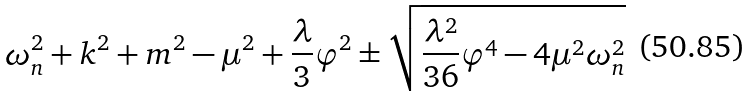Convert formula to latex. <formula><loc_0><loc_0><loc_500><loc_500>\omega _ { n } ^ { 2 } + k ^ { 2 } + m ^ { 2 } - \mu ^ { 2 } + \frac { \lambda } { 3 } \varphi ^ { 2 } \pm \sqrt { \frac { \lambda ^ { 2 } } { 3 6 } \varphi ^ { 4 } - 4 \mu ^ { 2 } \omega _ { n } ^ { 2 } }</formula> 